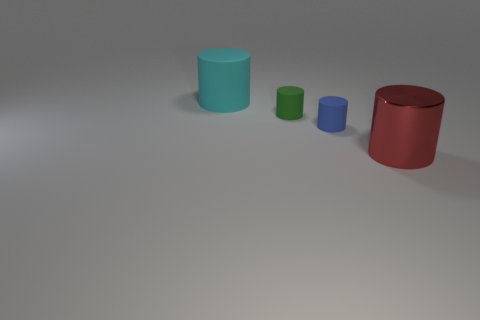Add 4 small matte things. How many objects exist? 8 Add 4 small blue cylinders. How many small blue cylinders are left? 5 Add 1 small blue rubber spheres. How many small blue rubber spheres exist? 1 Subtract 0 green cubes. How many objects are left? 4 Subtract all big cyan rubber cylinders. Subtract all metallic objects. How many objects are left? 2 